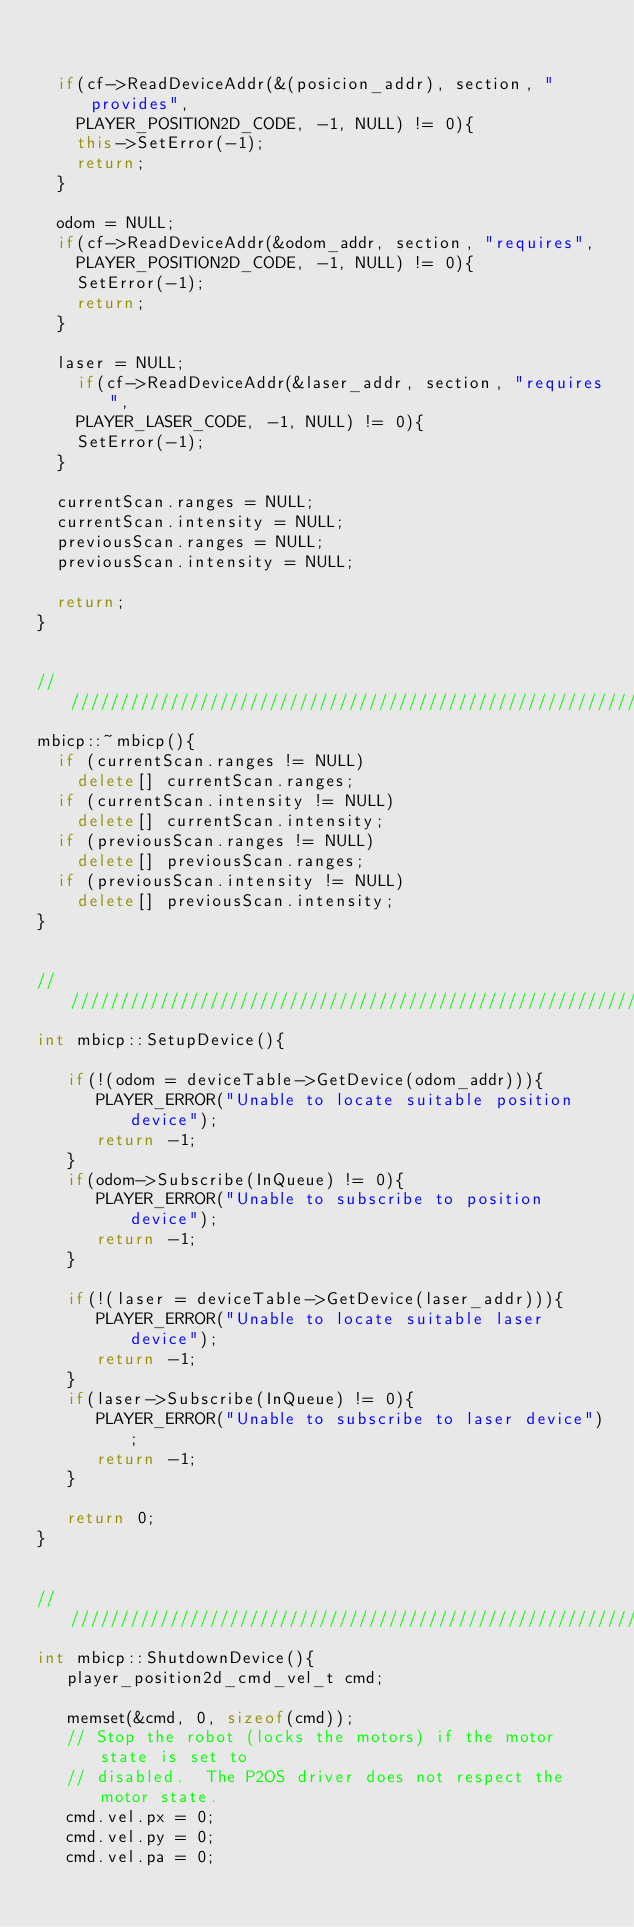Convert code to text. <code><loc_0><loc_0><loc_500><loc_500><_C++_>

	if(cf->ReadDeviceAddr(&(posicion_addr), section, "provides",
		PLAYER_POSITION2D_CODE, -1, NULL) != 0){
		this->SetError(-1);
		return;
	}

	odom = NULL;
	if(cf->ReadDeviceAddr(&odom_addr, section, "requires",
		PLAYER_POSITION2D_CODE, -1, NULL) != 0){
		SetError(-1);
		return;
	}

	laser = NULL;
		if(cf->ReadDeviceAddr(&laser_addr, section, "requires",
		PLAYER_LASER_CODE, -1, NULL) != 0){
		SetError(-1);
	}

	currentScan.ranges = NULL;
	currentScan.intensity = NULL;
	previousScan.ranges = NULL;
	previousScan.intensity = NULL;

	return;
}


////////////////////////////////////////////////////////////////////////////////
mbicp::~mbicp(){
	if (currentScan.ranges != NULL)
		delete[] currentScan.ranges;
	if (currentScan.intensity != NULL)
		delete[] currentScan.intensity;
	if (previousScan.ranges != NULL)
		delete[] previousScan.ranges;
	if (previousScan.intensity != NULL)
		delete[] previousScan.intensity;
}


////////////////////////////////////////////////////////////////////////////////
int mbicp::SetupDevice(){

   if(!(odom = deviceTable->GetDevice(odom_addr))){
      PLAYER_ERROR("Unable to locate suitable position device");
      return -1;
   }
   if(odom->Subscribe(InQueue) != 0){
      PLAYER_ERROR("Unable to subscribe to position device");
      return -1;
   }

   if(!(laser = deviceTable->GetDevice(laser_addr))){
      PLAYER_ERROR("Unable to locate suitable laser device");
      return -1;
   }
   if(laser->Subscribe(InQueue) != 0){
      PLAYER_ERROR("Unable to subscribe to laser device");
      return -1;
   }

   return 0;
}


////////////////////////////////////////////////////////////////////////////////
int mbicp::ShutdownDevice(){
   player_position2d_cmd_vel_t cmd;

   memset(&cmd, 0, sizeof(cmd));
   // Stop the robot (locks the motors) if the motor state is set to
   // disabled.  The P2OS driver does not respect the motor state.
   cmd.vel.px = 0;
   cmd.vel.py = 0;
   cmd.vel.pa = 0;
</code> 